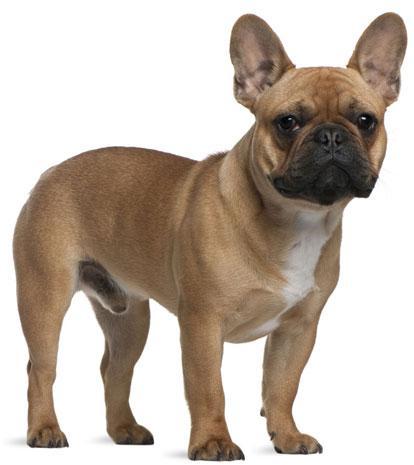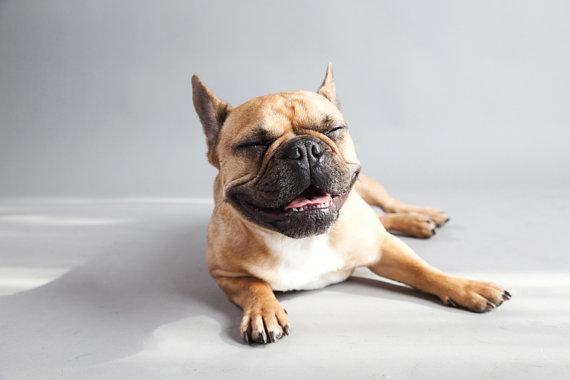The first image is the image on the left, the second image is the image on the right. Assess this claim about the two images: "In one of the images there is a single puppy lying on the floor.". Correct or not? Answer yes or no. Yes. 